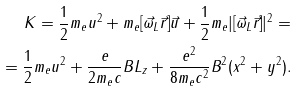<formula> <loc_0><loc_0><loc_500><loc_500>K = \frac { 1 } { 2 } m _ { e } u ^ { 2 } + m _ { e } [ \vec { \omega } _ { L } \vec { r } ] \vec { u } + \frac { 1 } { 2 } m _ { e } | [ \vec { \omega } _ { L } \vec { r } ] | ^ { 2 } = \\ = \frac { 1 } { 2 } m _ { e } u ^ { 2 } + \frac { e } { 2 m _ { e } c } B L _ { z } + \frac { e ^ { 2 } } { 8 m _ { e } c ^ { 2 } } B ^ { 2 } ( x ^ { 2 } + y ^ { 2 } ) .</formula> 